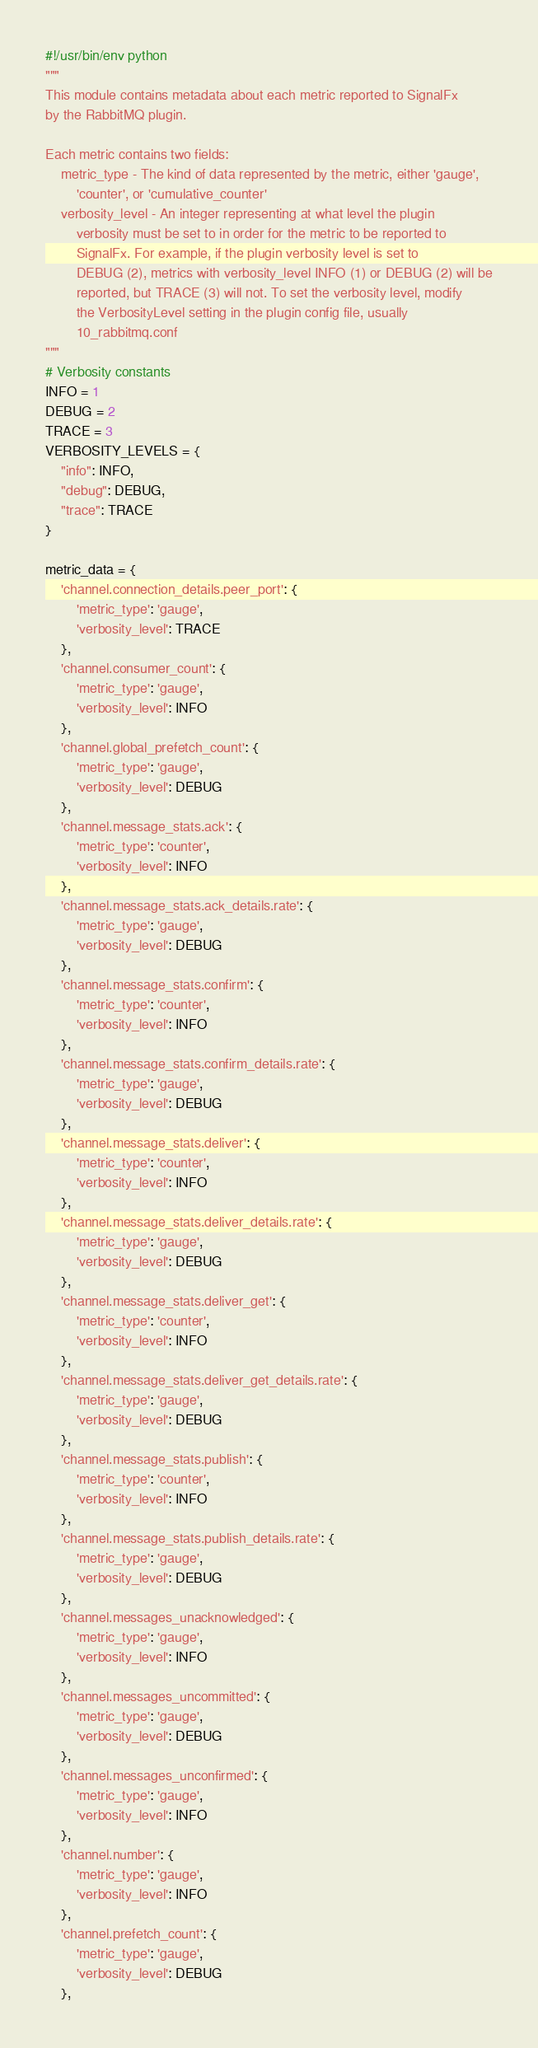<code> <loc_0><loc_0><loc_500><loc_500><_Python_>#!/usr/bin/env python
"""
This module contains metadata about each metric reported to SignalFx
by the RabbitMQ plugin.

Each metric contains two fields:
    metric_type - The kind of data represented by the metric, either 'gauge',
        'counter', or 'cumulative_counter'
    verbosity_level - An integer representing at what level the plugin
        verbosity must be set to in order for the metric to be reported to
        SignalFx. For example, if the plugin verbosity level is set to
        DEBUG (2), metrics with verbosity_level INFO (1) or DEBUG (2) will be
        reported, but TRACE (3) will not. To set the verbosity level, modify
        the VerbosityLevel setting in the plugin config file, usually
        10_rabbitmq.conf
"""
# Verbosity constants
INFO = 1
DEBUG = 2
TRACE = 3
VERBOSITY_LEVELS = {
    "info": INFO,
    "debug": DEBUG,
    "trace": TRACE
}

metric_data = {
    'channel.connection_details.peer_port': {
        'metric_type': 'gauge',
        'verbosity_level': TRACE
    },
    'channel.consumer_count': {
        'metric_type': 'gauge',
        'verbosity_level': INFO
    },
    'channel.global_prefetch_count': {
        'metric_type': 'gauge',
        'verbosity_level': DEBUG
    },
    'channel.message_stats.ack': {
        'metric_type': 'counter',
        'verbosity_level': INFO
    },
    'channel.message_stats.ack_details.rate': {
        'metric_type': 'gauge',
        'verbosity_level': DEBUG
    },
    'channel.message_stats.confirm': {
        'metric_type': 'counter',
        'verbosity_level': INFO
    },
    'channel.message_stats.confirm_details.rate': {
        'metric_type': 'gauge',
        'verbosity_level': DEBUG
    },
    'channel.message_stats.deliver': {
        'metric_type': 'counter',
        'verbosity_level': INFO
    },
    'channel.message_stats.deliver_details.rate': {
        'metric_type': 'gauge',
        'verbosity_level': DEBUG
    },
    'channel.message_stats.deliver_get': {
        'metric_type': 'counter',
        'verbosity_level': INFO
    },
    'channel.message_stats.deliver_get_details.rate': {
        'metric_type': 'gauge',
        'verbosity_level': DEBUG
    },
    'channel.message_stats.publish': {
        'metric_type': 'counter',
        'verbosity_level': INFO
    },
    'channel.message_stats.publish_details.rate': {
        'metric_type': 'gauge',
        'verbosity_level': DEBUG
    },
    'channel.messages_unacknowledged': {
        'metric_type': 'gauge',
        'verbosity_level': INFO
    },
    'channel.messages_uncommitted': {
        'metric_type': 'gauge',
        'verbosity_level': DEBUG
    },
    'channel.messages_unconfirmed': {
        'metric_type': 'gauge',
        'verbosity_level': INFO
    },
    'channel.number': {
        'metric_type': 'gauge',
        'verbosity_level': INFO
    },
    'channel.prefetch_count': {
        'metric_type': 'gauge',
        'verbosity_level': DEBUG
    },</code> 